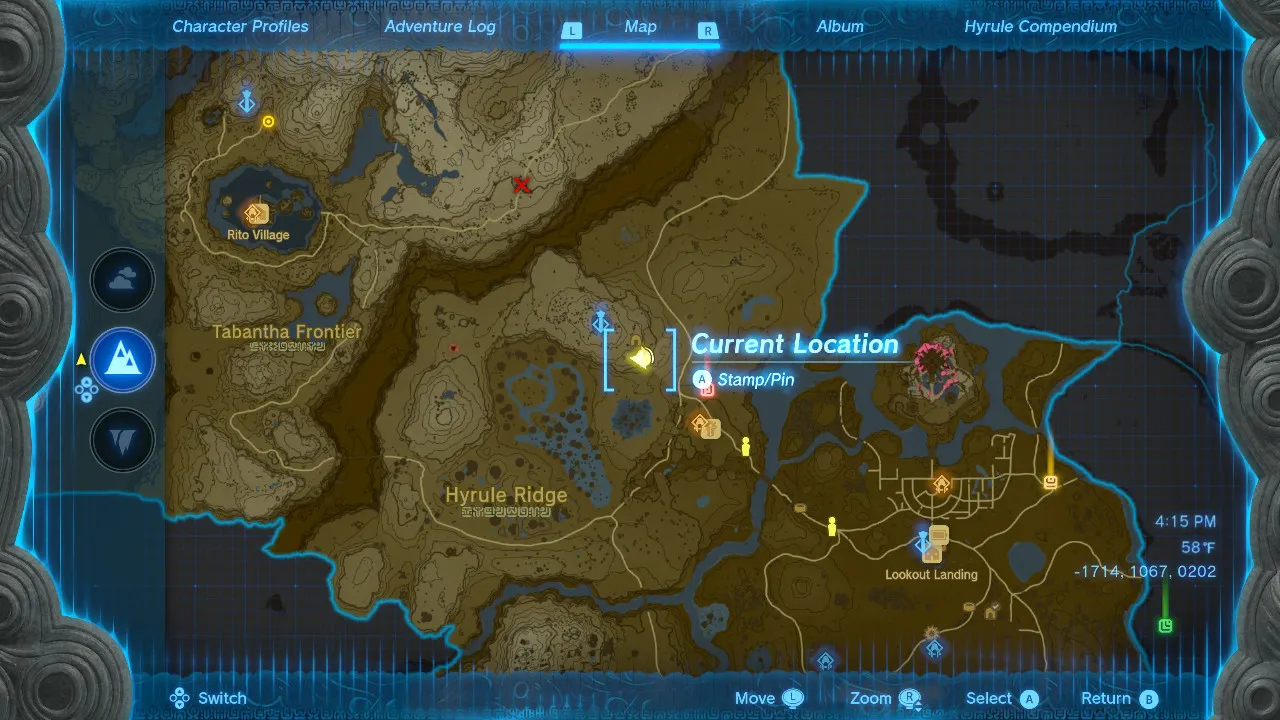Given my horse's location on this map, what is the quickest route to reach it? In the game "The Legend of Zelda: Breath of the Wild," the quickest route to your horse would depend on the equipment and abilities you have available. Assuming you have the standard abilities, here is a general route you could take:

1. From your current location, head directly east towards the road that appears to cut through the valley. It's the path that runs north to south near the center of the image, east of your current location.

2. Once you hit the road, follow it northward. This road will take you around the mountainous terrain and should provide a relatively clear path.

3. Continue on the road as it curves to the west and then to the north again, making sure to stay on the main path to avoid steep terrain.

4. As you approach the area where your horse is, look for the most direct way to leave the road and head towards your horse's icon on the map.

If you have the ability to glide using the Paraglider, you could consider climbing to a high point near your current location and then gliding down towards the road to save time. Similarly, if you have access to fast-travel via Shrines or Towers, you could teleport closer to your horse if there is an unlocked travel point nearby. 